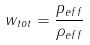<formula> <loc_0><loc_0><loc_500><loc_500>w _ { t o t } = \frac { p _ { e f f } } { \rho _ { e f f } }</formula> 